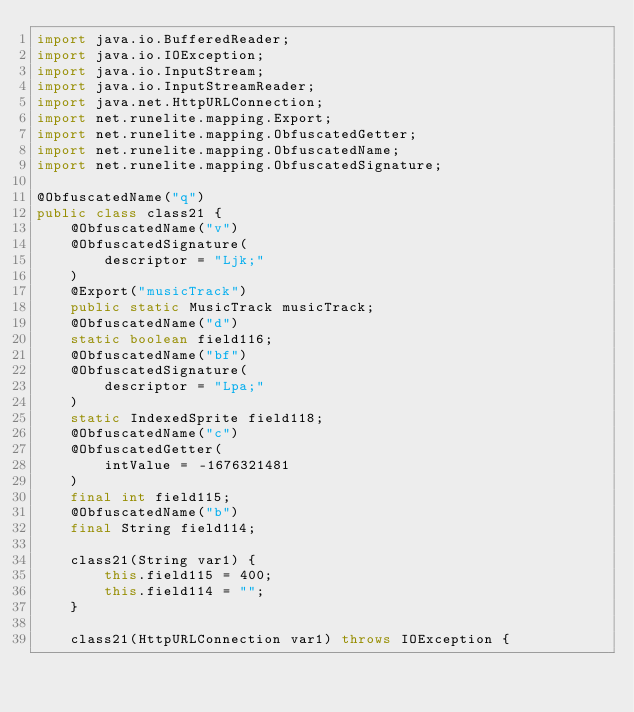Convert code to text. <code><loc_0><loc_0><loc_500><loc_500><_Java_>import java.io.BufferedReader;
import java.io.IOException;
import java.io.InputStream;
import java.io.InputStreamReader;
import java.net.HttpURLConnection;
import net.runelite.mapping.Export;
import net.runelite.mapping.ObfuscatedGetter;
import net.runelite.mapping.ObfuscatedName;
import net.runelite.mapping.ObfuscatedSignature;

@ObfuscatedName("q")
public class class21 {
	@ObfuscatedName("v")
	@ObfuscatedSignature(
		descriptor = "Ljk;"
	)
	@Export("musicTrack")
	public static MusicTrack musicTrack;
	@ObfuscatedName("d")
	static boolean field116;
	@ObfuscatedName("bf")
	@ObfuscatedSignature(
		descriptor = "Lpa;"
	)
	static IndexedSprite field118;
	@ObfuscatedName("c")
	@ObfuscatedGetter(
		intValue = -1676321481
	)
	final int field115;
	@ObfuscatedName("b")
	final String field114;

	class21(String var1) {
		this.field115 = 400;
		this.field114 = "";
	}

	class21(HttpURLConnection var1) throws IOException {</code> 